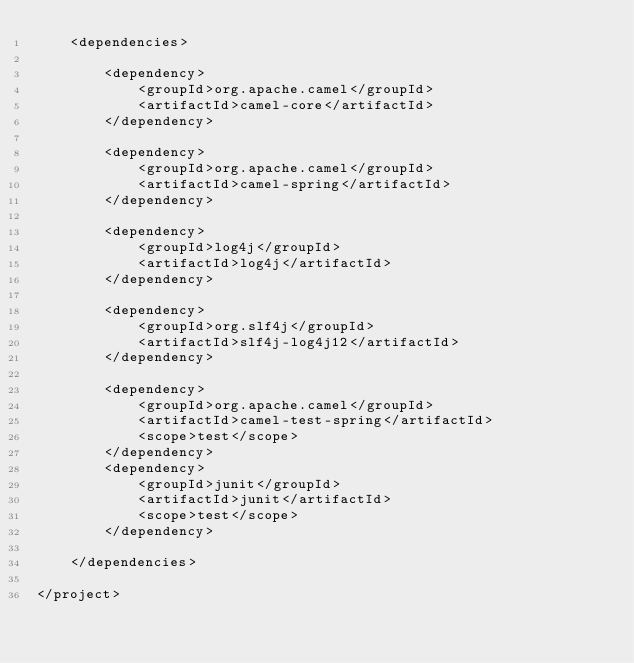Convert code to text. <code><loc_0><loc_0><loc_500><loc_500><_XML_>    <dependencies>

        <dependency>
            <groupId>org.apache.camel</groupId>
            <artifactId>camel-core</artifactId>
        </dependency>

        <dependency>
            <groupId>org.apache.camel</groupId>
            <artifactId>camel-spring</artifactId>
        </dependency>

        <dependency>
            <groupId>log4j</groupId>
            <artifactId>log4j</artifactId>
        </dependency>
        
        <dependency>
            <groupId>org.slf4j</groupId>
            <artifactId>slf4j-log4j12</artifactId>
        </dependency>

        <dependency>
            <groupId>org.apache.camel</groupId>
            <artifactId>camel-test-spring</artifactId>
            <scope>test</scope>
        </dependency>
        <dependency>
            <groupId>junit</groupId>
            <artifactId>junit</artifactId>
            <scope>test</scope>
        </dependency>

    </dependencies>

</project>

</code> 